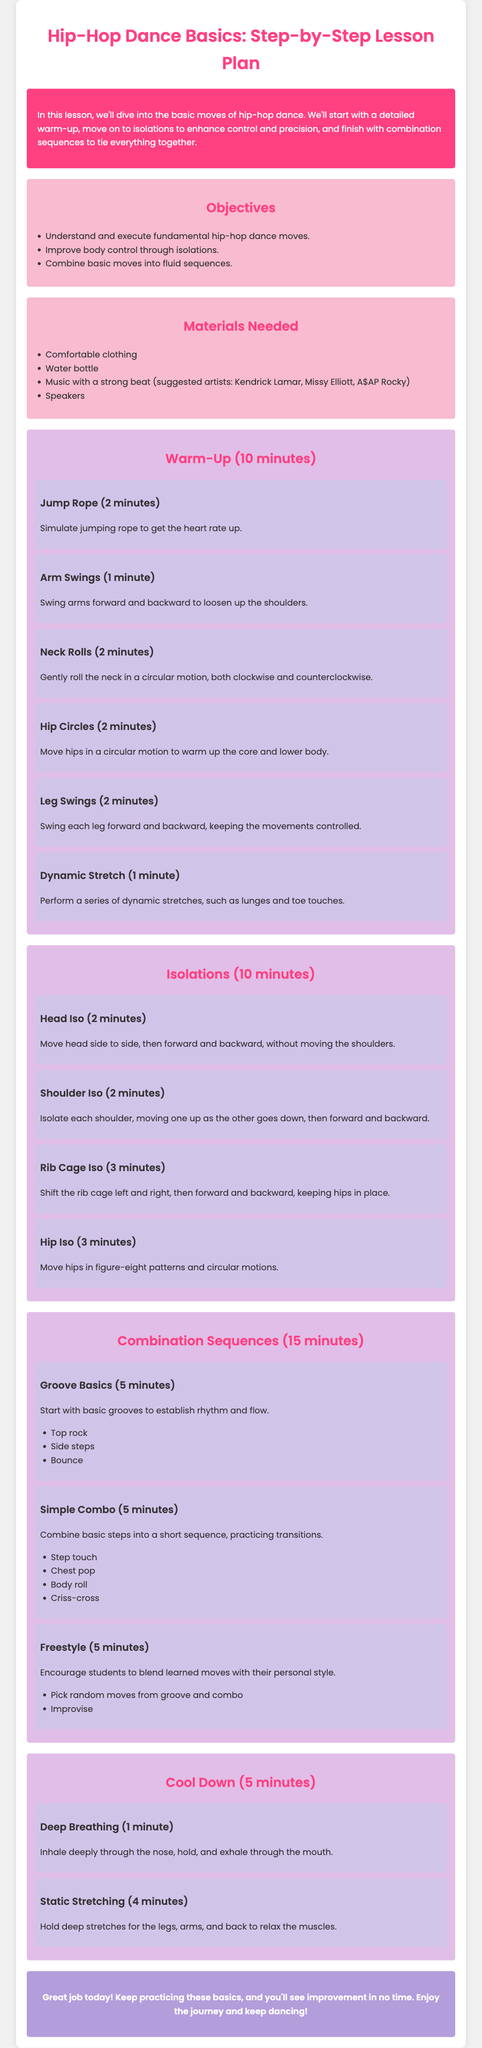What is the title of the lesson plan? The title is prominently featured at the top of the document, indicating the subject of the lesson.
Answer: Hip-Hop Dance Basics: Step-by-Step Lesson Plan What is the duration of the warm-up? The section header specifies the amount of time allotted for the warm-up activity in the lesson plan.
Answer: 10 minutes How many basic moves are mentioned in the combination sequences? The number of steps is detailed within the combination sequences section, outlining the components of the dance practice.
Answer: 3 What are the materials needed for the lesson? A list of necessary items for participating in the lesson is provided in the materials section.
Answer: Comfortable clothing, Water bottle, Music with a strong beat, Speakers Which artist is suggested for the music? The document provides examples of artists to listen to during the dance lesson, indicated in the materials section.
Answer: Kendrick Lamar What is the final step in the cool down? The last activity specified in the cool down section highlights how to conclude the lesson effectively.
Answer: Static Stretching What is the objective about improving body control? One of the objectives focuses on enhancing a specific skill, as stated clearly in the objectives section.
Answer: Improve body control through isolations How long is the freestyle section? The duration for this creative section is clearly noted in the lesson plan document.
Answer: 5 minutes 